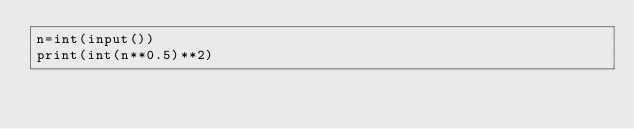Convert code to text. <code><loc_0><loc_0><loc_500><loc_500><_Python_>n=int(input())
print(int(n**0.5)**2)</code> 